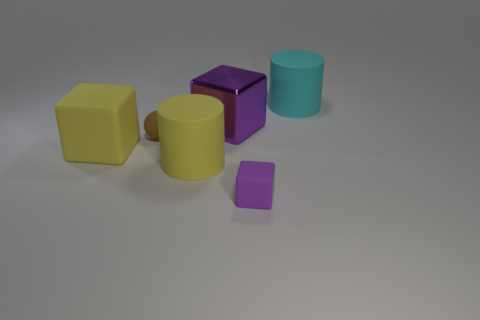Subtract all purple rubber blocks. How many blocks are left? 2 Subtract all red cylinders. How many purple blocks are left? 2 Subtract all yellow cubes. How many cubes are left? 2 Add 1 big yellow things. How many objects exist? 7 Subtract 1 spheres. How many spheres are left? 0 Subtract all balls. How many objects are left? 5 Subtract all gray blocks. Subtract all green balls. How many blocks are left? 3 Subtract all large cyan cylinders. Subtract all metallic things. How many objects are left? 4 Add 3 large purple cubes. How many large purple cubes are left? 4 Add 5 tiny metallic cylinders. How many tiny metallic cylinders exist? 5 